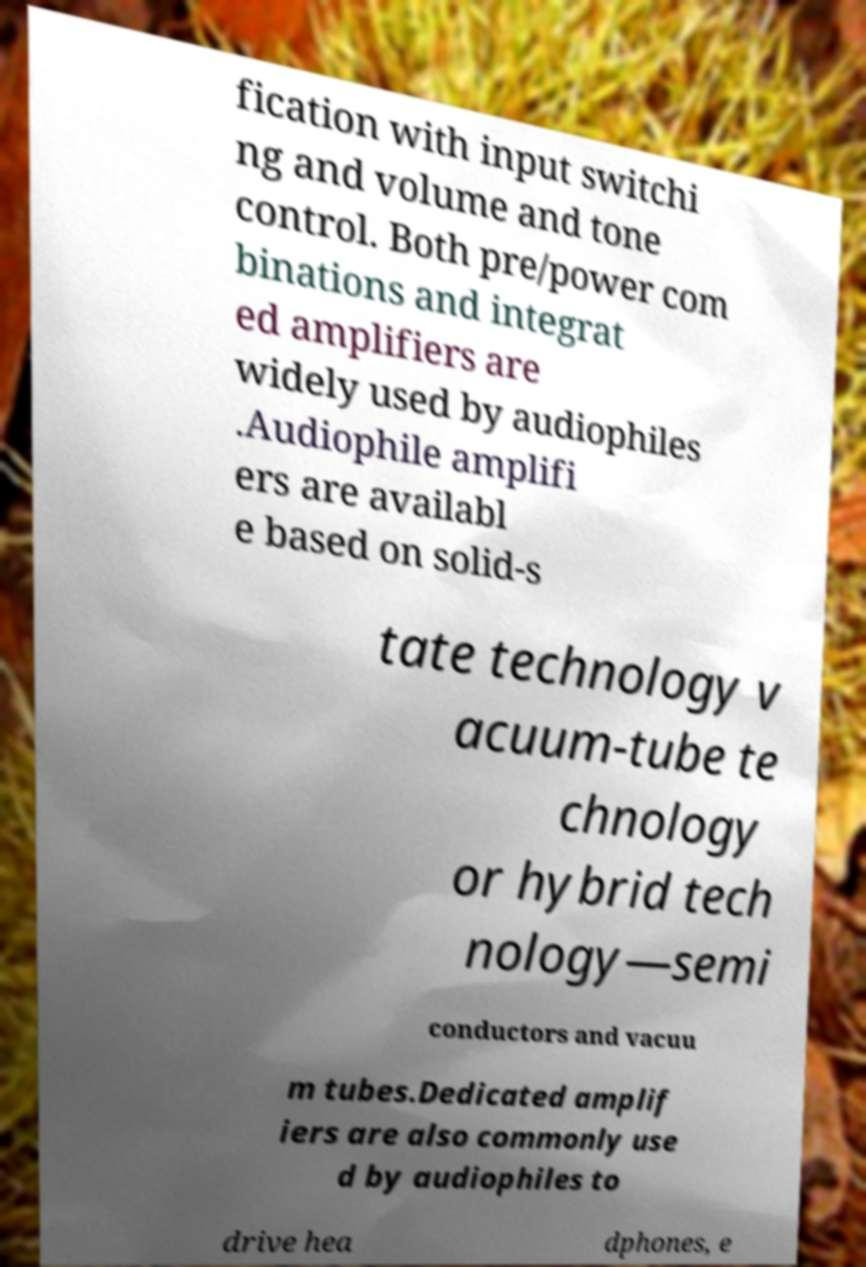Can you read and provide the text displayed in the image?This photo seems to have some interesting text. Can you extract and type it out for me? fication with input switchi ng and volume and tone control. Both pre/power com binations and integrat ed amplifiers are widely used by audiophiles .Audiophile amplifi ers are availabl e based on solid-s tate technology v acuum-tube te chnology or hybrid tech nology—semi conductors and vacuu m tubes.Dedicated amplif iers are also commonly use d by audiophiles to drive hea dphones, e 